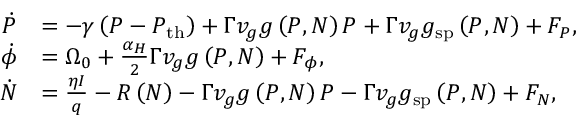<formula> <loc_0><loc_0><loc_500><loc_500>\begin{array} { r l } { \dot { P } } & { = - \gamma \left ( P - P _ { t h } \right ) + \Gamma v _ { g } g \left ( P , N \right ) P + \Gamma v _ { g } g _ { s p } \left ( P , N \right ) + F _ { P } , } \\ { \dot { \phi } } & { = \Omega _ { 0 } + \frac { \alpha _ { H } } { 2 } \Gamma v _ { g } g \left ( P , N \right ) + F _ { \phi } , } \\ { \dot { N } } & { = \frac { \eta I } { q } - R \left ( N \right ) - \Gamma v _ { g } g \left ( P , N \right ) P - \Gamma v _ { g } g _ { s p } \left ( P , N \right ) + F _ { N } , } \end{array}</formula> 